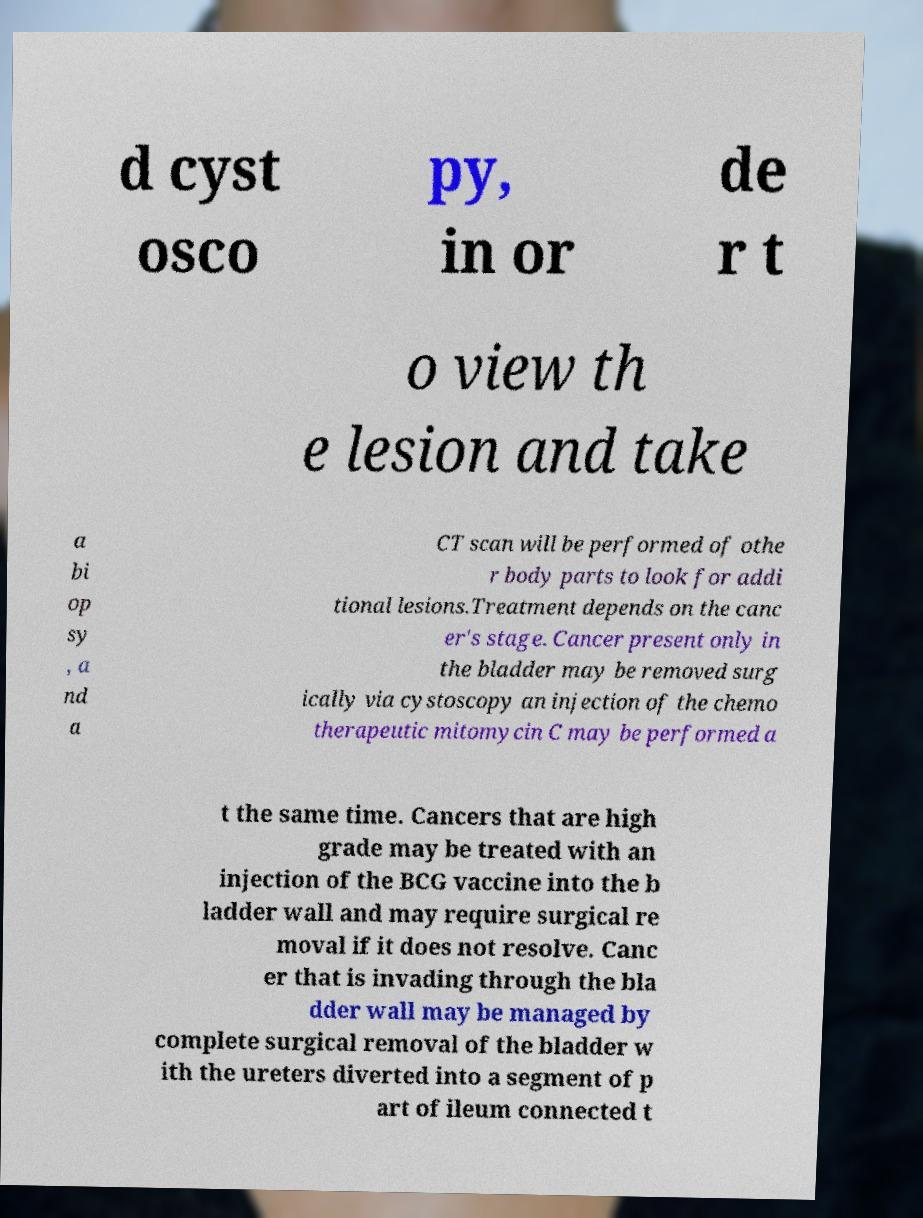I need the written content from this picture converted into text. Can you do that? d cyst osco py, in or de r t o view th e lesion and take a bi op sy , a nd a CT scan will be performed of othe r body parts to look for addi tional lesions.Treatment depends on the canc er's stage. Cancer present only in the bladder may be removed surg ically via cystoscopy an injection of the chemo therapeutic mitomycin C may be performed a t the same time. Cancers that are high grade may be treated with an injection of the BCG vaccine into the b ladder wall and may require surgical re moval if it does not resolve. Canc er that is invading through the bla dder wall may be managed by complete surgical removal of the bladder w ith the ureters diverted into a segment of p art of ileum connected t 